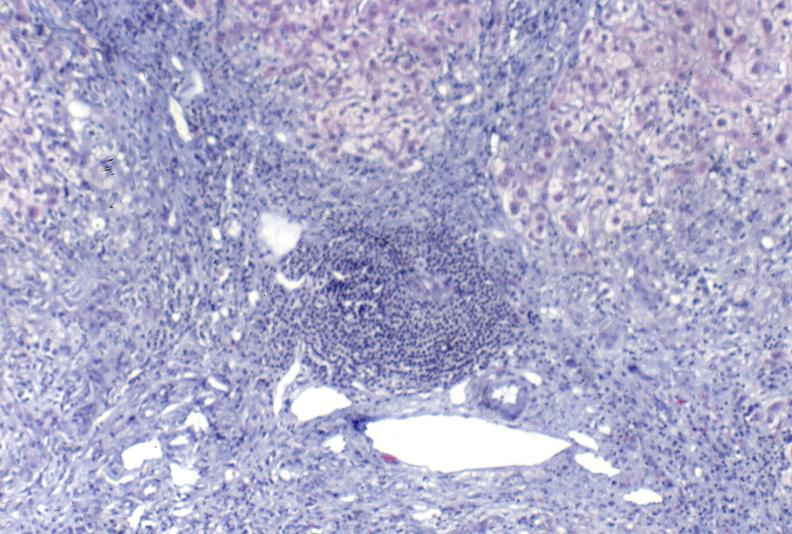does malignant histiocytosis show primary biliary cirrhosis?
Answer the question using a single word or phrase. No 